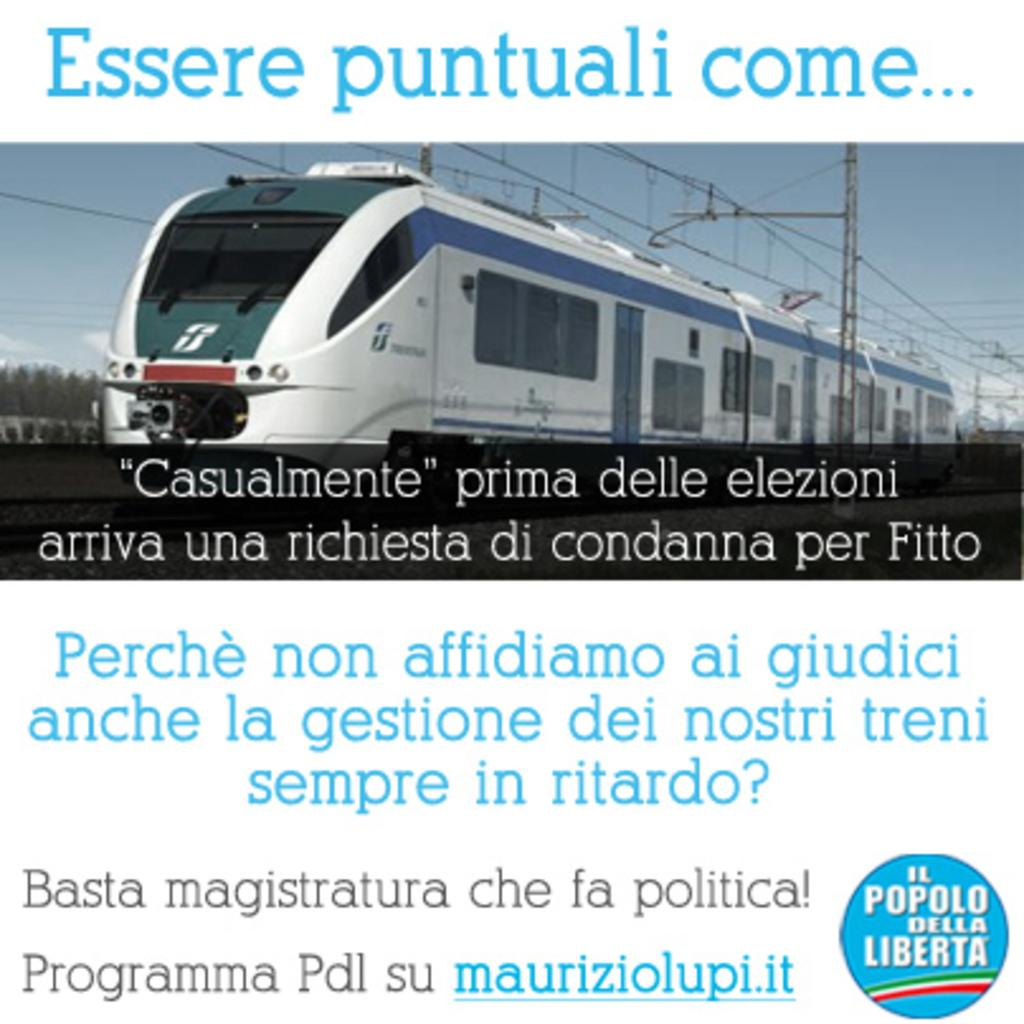What is featured on the poster in the image? The poster contains a logo, an image of a train, poles, cables, trees, and the sky. Are there any words on the poster? Yes, there are words on the poster. What type of transportation is depicted on the poster? The poster features an image of a train. What other elements are present on the poster? Poles, cables, trees, and the sky are depicted on the poster. How many planes can be seen flying over the bridge in the image? There are no planes or bridges present in the image; it features a poster with various elements, including a train, poles, cables, trees, and the sky. 